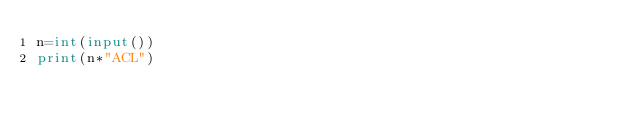Convert code to text. <code><loc_0><loc_0><loc_500><loc_500><_Python_>n=int(input())
print(n*"ACL")</code> 